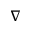Convert formula to latex. <formula><loc_0><loc_0><loc_500><loc_500>\nabla</formula> 